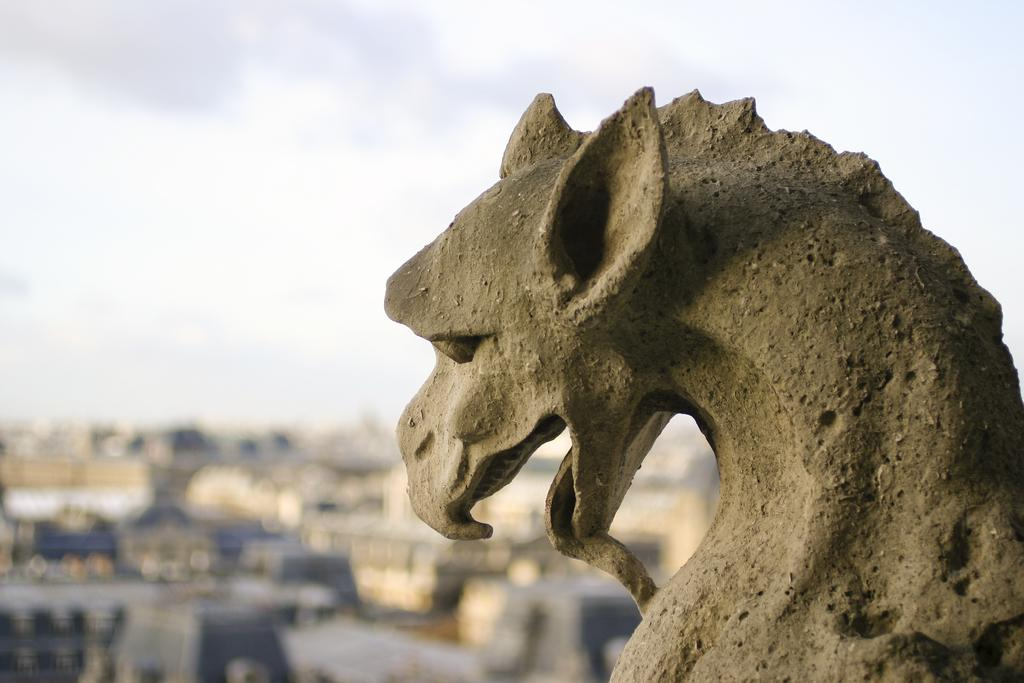What is the main subject of the image? There is a statue in the image. What is the statue shaped like? The statue is in the shape of a dragon. What can be seen in the background of the image? The sky is visible in the image. How would you describe the weather based on the sky in the image? The sky appears to be cloudy, which might suggest overcast or potentially rainy weather. What type of cup can be seen hanging from the dragon's mouth in the image? There is no cup present in the image, and the dragon's mouth is not depicted as holding or containing any object. 